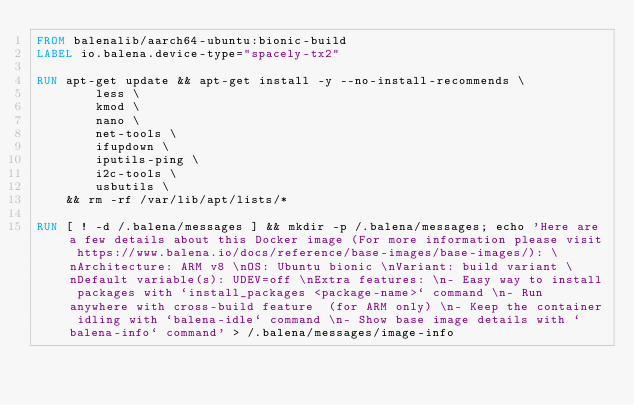Convert code to text. <code><loc_0><loc_0><loc_500><loc_500><_Dockerfile_>FROM balenalib/aarch64-ubuntu:bionic-build
LABEL io.balena.device-type="spacely-tx2"

RUN apt-get update && apt-get install -y --no-install-recommends \
		less \
		kmod \
		nano \
		net-tools \
		ifupdown \
		iputils-ping \
		i2c-tools \
		usbutils \
	&& rm -rf /var/lib/apt/lists/*

RUN [ ! -d /.balena/messages ] && mkdir -p /.balena/messages; echo 'Here are a few details about this Docker image (For more information please visit https://www.balena.io/docs/reference/base-images/base-images/): \nArchitecture: ARM v8 \nOS: Ubuntu bionic \nVariant: build variant \nDefault variable(s): UDEV=off \nExtra features: \n- Easy way to install packages with `install_packages <package-name>` command \n- Run anywhere with cross-build feature  (for ARM only) \n- Keep the container idling with `balena-idle` command \n- Show base image details with `balena-info` command' > /.balena/messages/image-info</code> 